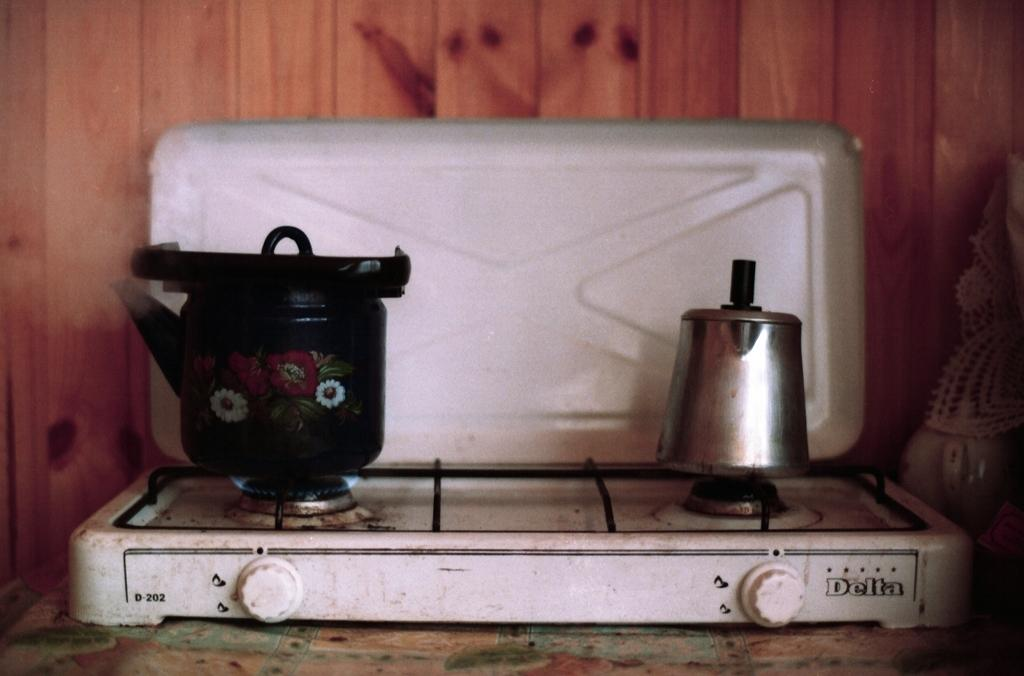<image>
Share a concise interpretation of the image provided. A Delta brand gas stove with a percolater and a kettle on top. 